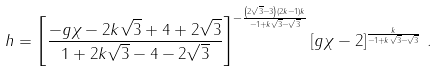<formula> <loc_0><loc_0><loc_500><loc_500>h = \left [ \frac { - g \chi - 2 k \sqrt { 3 } + 4 + 2 \sqrt { 3 } } { 1 + 2 k \sqrt { 3 } - 4 - 2 \sqrt { 3 } } \right ] ^ { - \frac { \left ( 2 \sqrt { 3 } - 3 \right ) ( 2 k - 1 ) k } { - 1 + k \sqrt { 3 } - \sqrt { 3 } } } \left [ g \chi - 2 \right ] ^ { \frac { k } { - 1 + k \sqrt { 3 } - \sqrt { 3 } } } \, .</formula> 